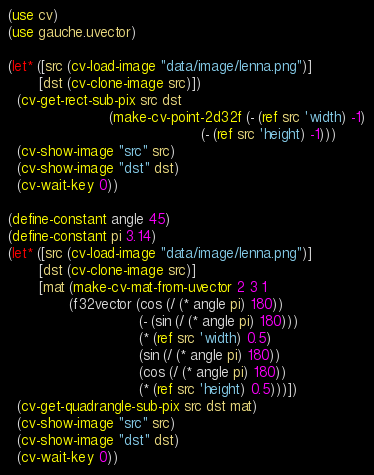Convert code to text. <code><loc_0><loc_0><loc_500><loc_500><_Scheme_>(use cv)
(use gauche.uvector)

(let* ([src (cv-load-image "data/image/lenna.png")]
       [dst (cv-clone-image src)])
  (cv-get-rect-sub-pix src dst 
                       (make-cv-point-2d32f (- (ref src 'width) -1)
                                            (- (ref src 'height) -1)))
  (cv-show-image "src" src)
  (cv-show-image "dst" dst)
  (cv-wait-key 0))

(define-constant angle 45)
(define-constant pi 3.14)
(let* ([src (cv-load-image "data/image/lenna.png")]
       [dst (cv-clone-image src)]
       [mat (make-cv-mat-from-uvector 2 3 1
              (f32vector (cos (/ (* angle pi) 180))
                              (- (sin (/ (* angle pi) 180)))
                              (* (ref src 'width) 0.5)
                              (sin (/ (* angle pi) 180))
                              (cos (/ (* angle pi) 180))
                              (* (ref src 'height) 0.5)))])
  (cv-get-quadrangle-sub-pix src dst mat)
  (cv-show-image "src" src)
  (cv-show-image "dst" dst)
  (cv-wait-key 0))


</code> 